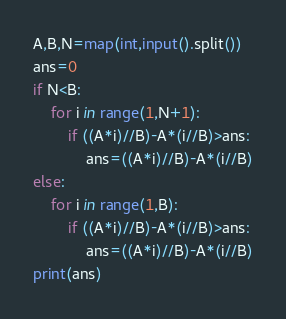Convert code to text. <code><loc_0><loc_0><loc_500><loc_500><_Python_>A,B,N=map(int,input().split())
ans=0
if N<B:
    for i in range(1,N+1):
        if ((A*i)//B)-A*(i//B)>ans:
            ans=((A*i)//B)-A*(i//B)
else:
    for i in range(1,B):
        if ((A*i)//B)-A*(i//B)>ans:
            ans=((A*i)//B)-A*(i//B)
print(ans)
</code> 